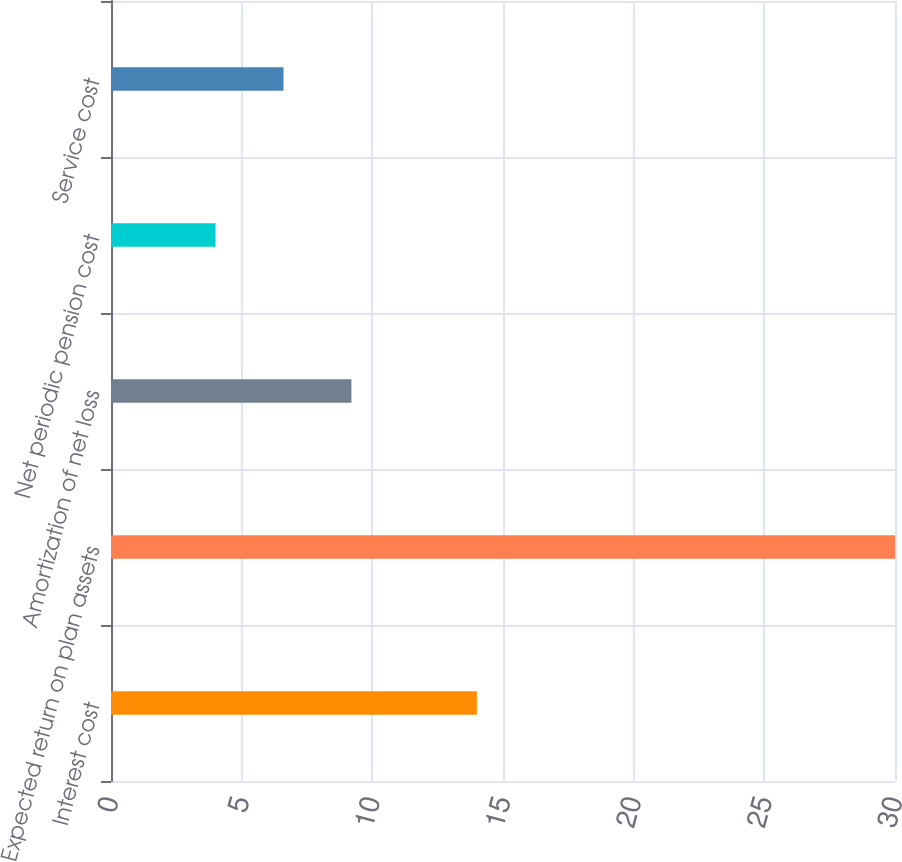Convert chart to OTSL. <chart><loc_0><loc_0><loc_500><loc_500><bar_chart><fcel>Interest cost<fcel>Expected return on plan assets<fcel>Amortization of net loss<fcel>Net periodic pension cost<fcel>Service cost<nl><fcel>14<fcel>30<fcel>9.2<fcel>4<fcel>6.6<nl></chart> 